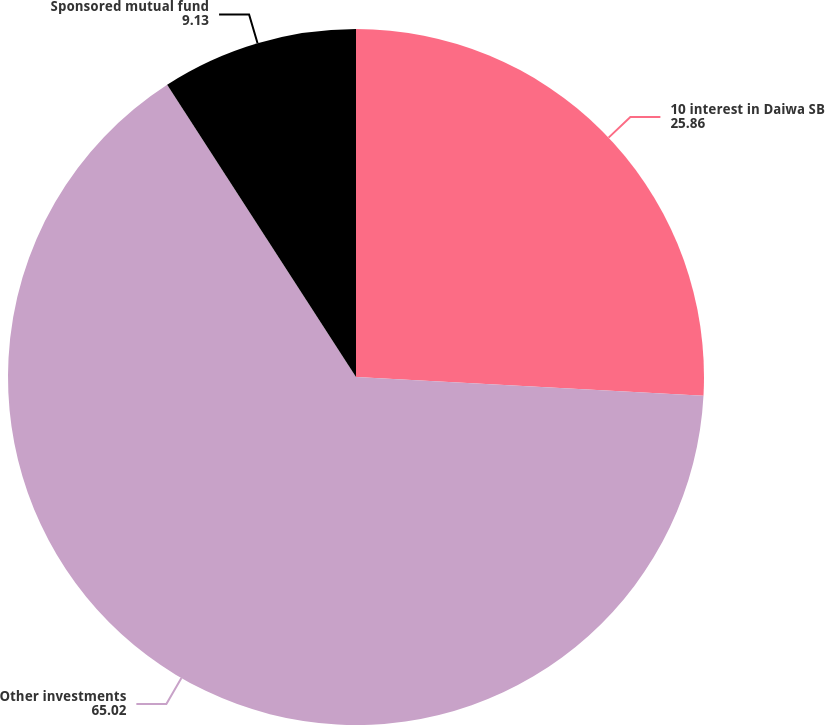Convert chart. <chart><loc_0><loc_0><loc_500><loc_500><pie_chart><fcel>10 interest in Daiwa SB<fcel>Other investments<fcel>Sponsored mutual fund<nl><fcel>25.86%<fcel>65.02%<fcel>9.13%<nl></chart> 